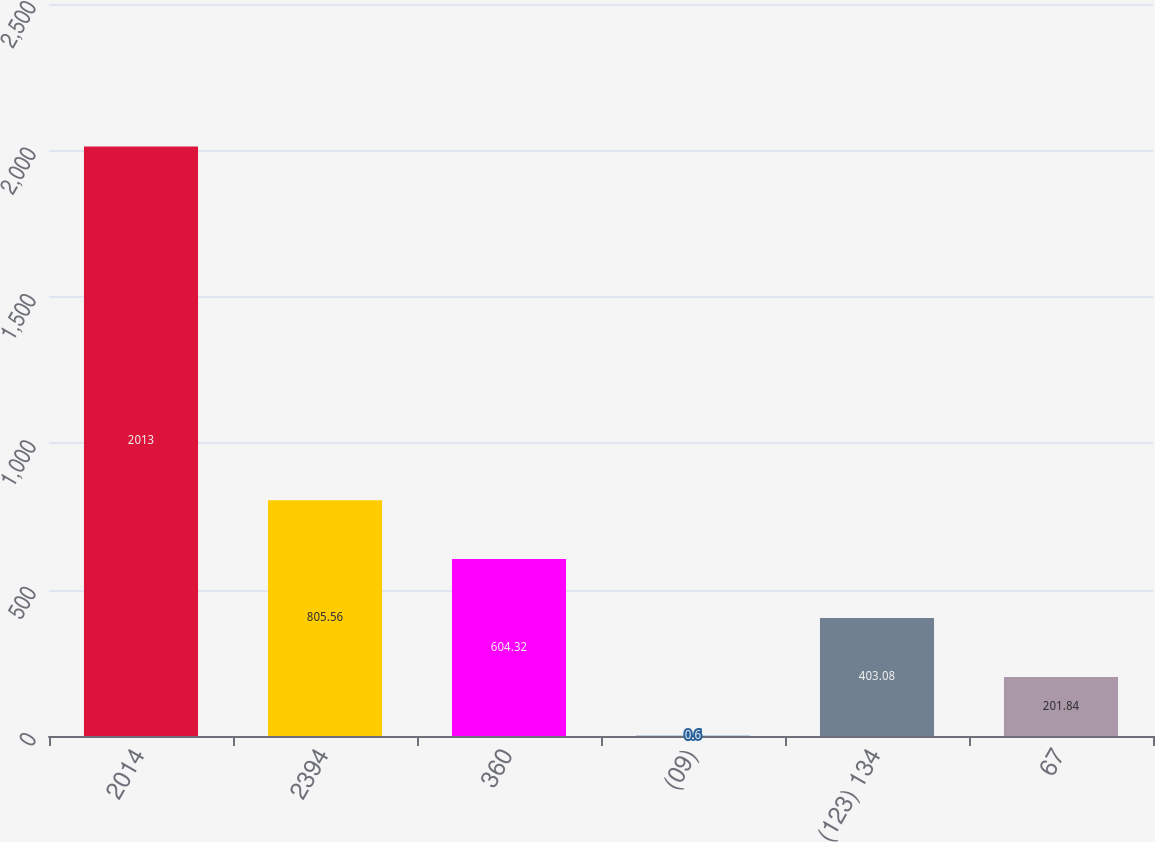Convert chart. <chart><loc_0><loc_0><loc_500><loc_500><bar_chart><fcel>2014<fcel>2394<fcel>360<fcel>(09)<fcel>(123) 134<fcel>67<nl><fcel>2013<fcel>805.56<fcel>604.32<fcel>0.6<fcel>403.08<fcel>201.84<nl></chart> 